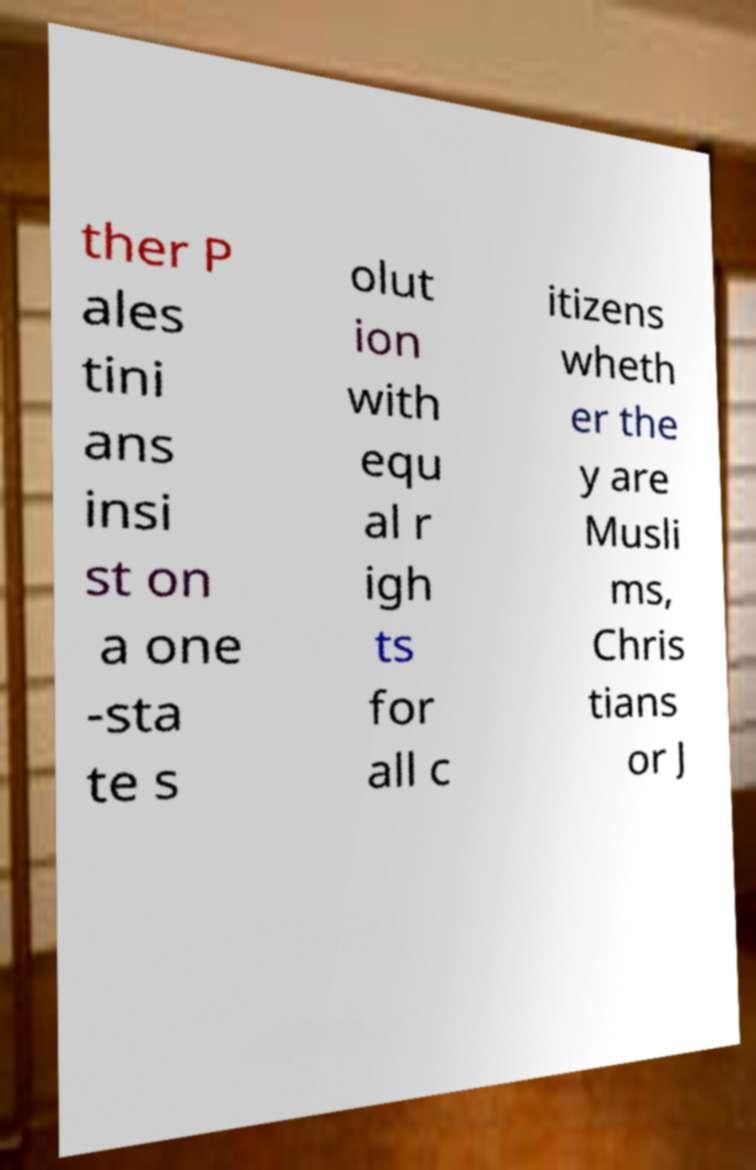There's text embedded in this image that I need extracted. Can you transcribe it verbatim? ther P ales tini ans insi st on a one -sta te s olut ion with equ al r igh ts for all c itizens wheth er the y are Musli ms, Chris tians or J 